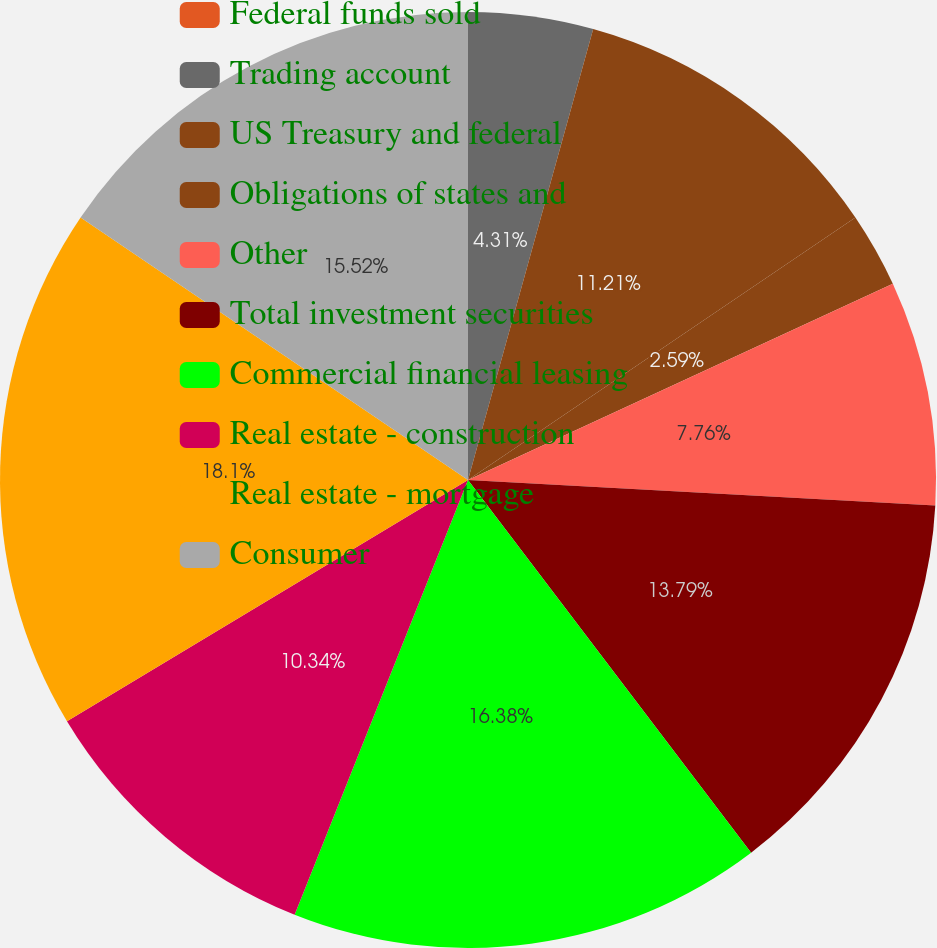Convert chart to OTSL. <chart><loc_0><loc_0><loc_500><loc_500><pie_chart><fcel>Federal funds sold<fcel>Trading account<fcel>US Treasury and federal<fcel>Obligations of states and<fcel>Other<fcel>Total investment securities<fcel>Commercial financial leasing<fcel>Real estate - construction<fcel>Real estate - mortgage<fcel>Consumer<nl><fcel>0.0%<fcel>4.31%<fcel>11.21%<fcel>2.59%<fcel>7.76%<fcel>13.79%<fcel>16.38%<fcel>10.34%<fcel>18.1%<fcel>15.52%<nl></chart> 